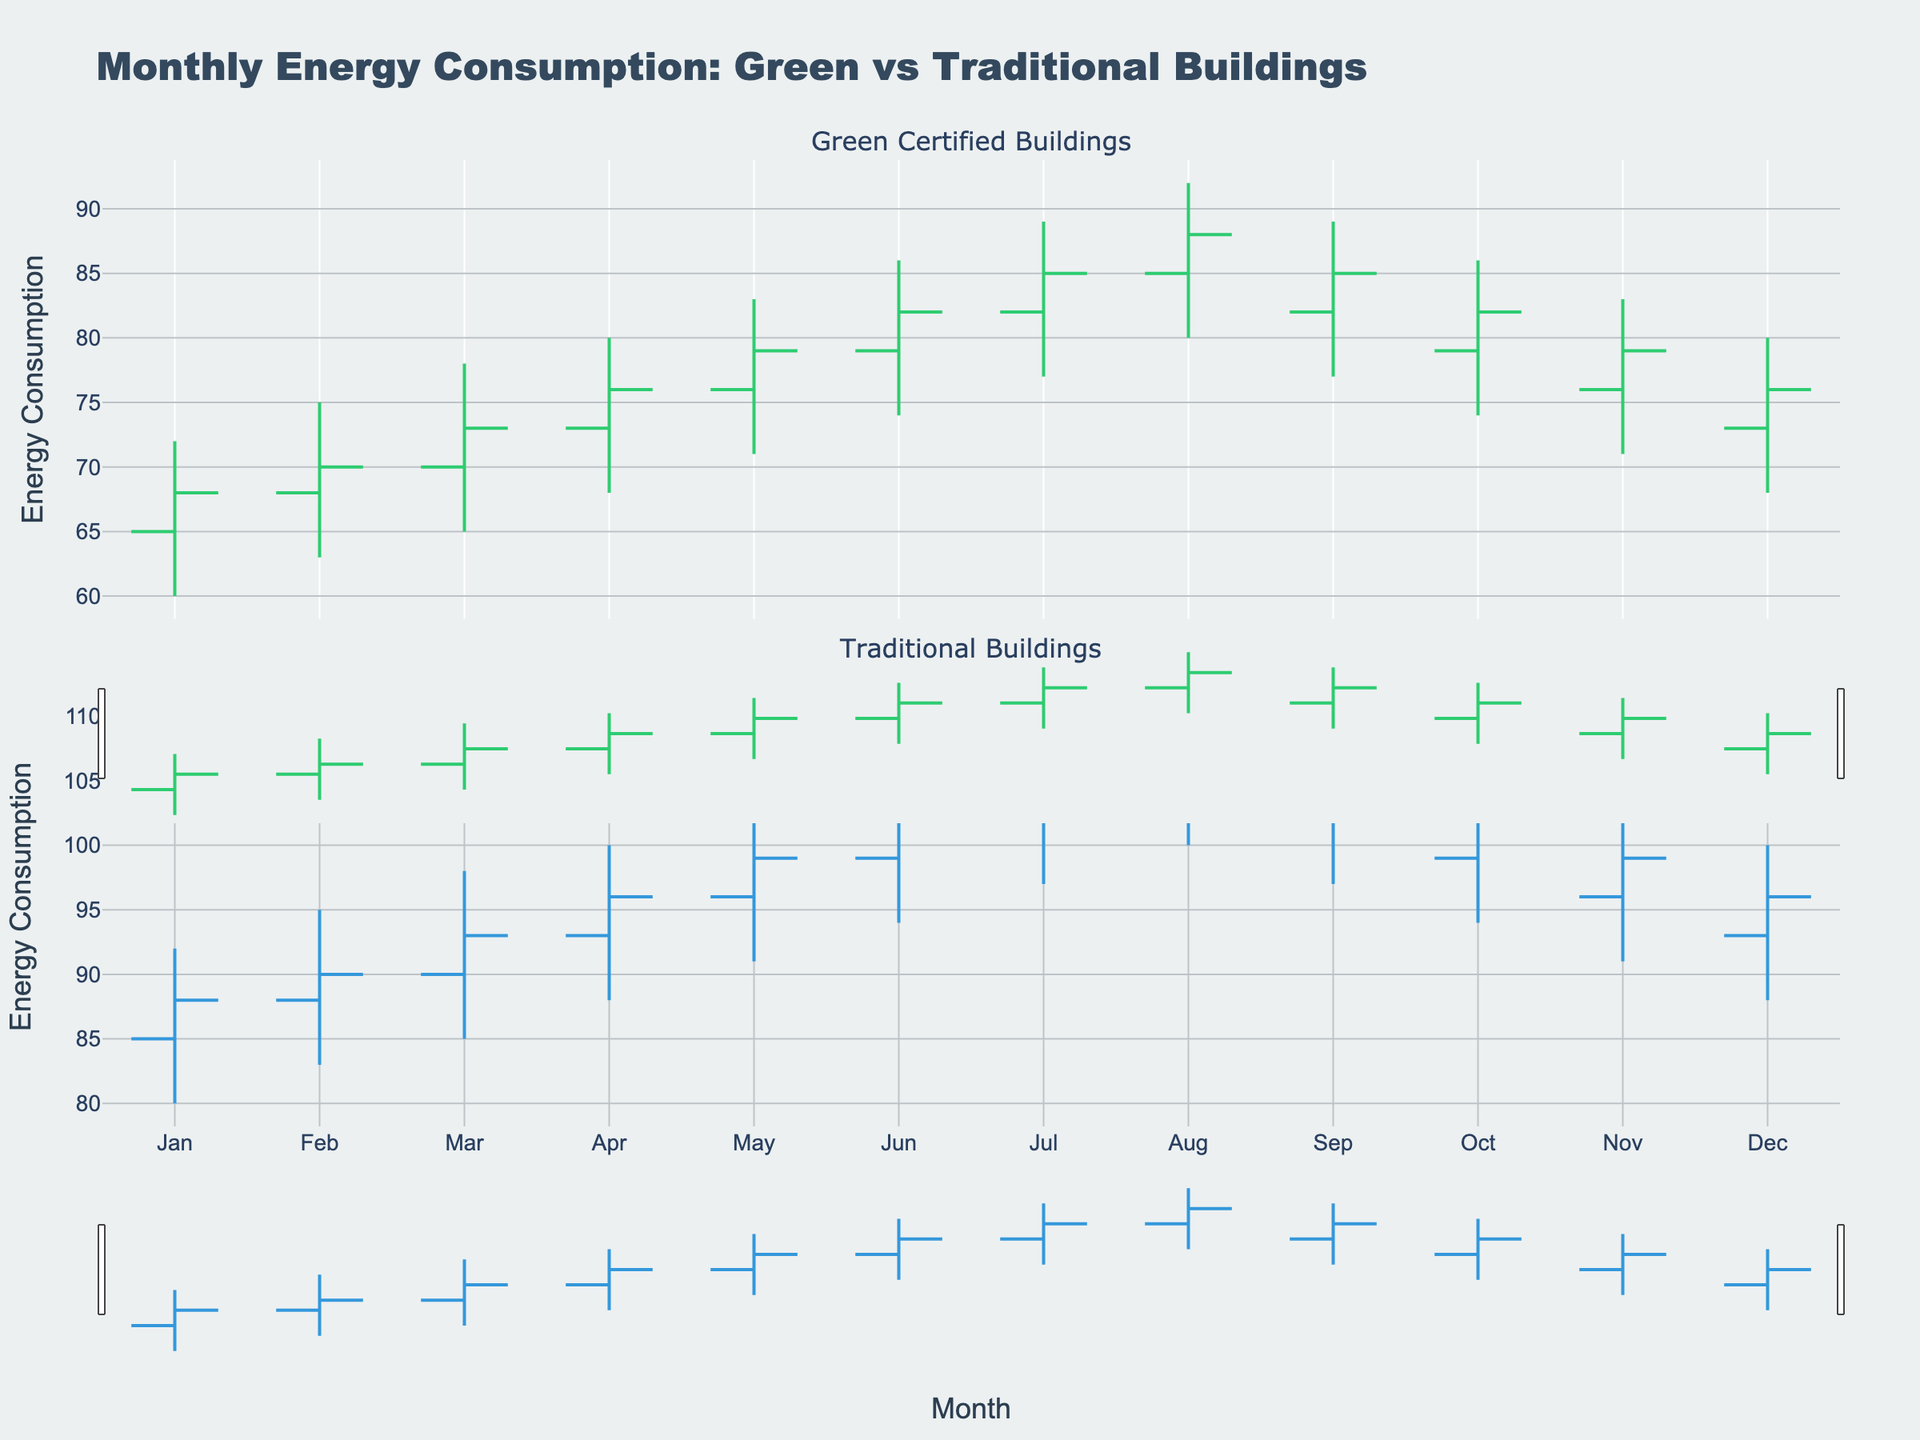What is the title of the chart? The title is usually found at the top of the chart, which generally gives an overview of what the chart is about.
Answer: Monthly Energy Consumption: Green vs Traditional Buildings What colors represent increasing energy consumption for Green Certified and Traditional buildings? The colors are generally indicated by the legend or the specific line or bar color in the graph. For this chart, the increasing line color for Green Certified is '#2ecc71', and for Traditional, it is '#3498db'.
Answer: Green Certified: green, Traditional: blue During which months did Green Certified buildings have their highest "High" value, and what was the value? The highest "High" value for Green Certified buildings is indicated by the peak in the corresponding subplot over the months. The highest value is observed in August with a value of 92.
Answer: August, 92 Which month shows the biggest difference in energy consumption between Green Certified and Traditional buildings at the "Close" value? To find this, look at the closing values for each month for both building types and identify the month with the largest difference between these values. In August, the "Close" value for Green Certified is 88 and for Traditional is 108, resulting in the largest difference of 20 units.
Answer: August, 20 How do the "Open" values for Green Certified buildings change from January to December? By checking the "Open" values for Green Certified buildings from January (65) to December (73), we notice an incremental trend as the values generally increase over the months.
Answer: Increase, from 65 to 73 Compare the "Close" value trends for Green Certified buildings in July and August. Do they increase or decrease? By checking the "Close" values for July (85) and August (88) for Green Certified buildings, we see that there is an increase from July to August.
Answer: Increase What visible trend can be observed in the "Low" values of Traditional buildings over the months? Observing the "Low" values of Traditional buildings for each month from January (80) to December (88), the "Low" values generally increase steadily over the months.
Answer: Increase What is the average "Close" value for Green Certified buildings over the year? The "Close" values for Green Certified buildings are 68, 70, 73, 76, 79, 82, 85, 88, 85, 82, 79, 76. Adding these (68 + 70 + 73 + 76 + 79 + 82 + 85 + 88 + 85 + 82 + 79 + 76) gives 943. Dividing by 12 months gives an average of approximately 78.58.
Answer: 78.58 In which month did Green Certified buildings have a decreasing energy consumption from open to close? Checking each month's Open and Close values for Green Certified buildings, we see that in October, the Open value (79) is higher than the Close value (82).
Answer: None Which building type shows higher energy consumption in the "Open" values throughout the year, and what is the general trend? Comparing the "Open" values every month, Traditional buildings start at a higher opening value (85 in January vs. 65 for Green Certified) and remain higher throughout the year.
Answer: Traditional, Higher 